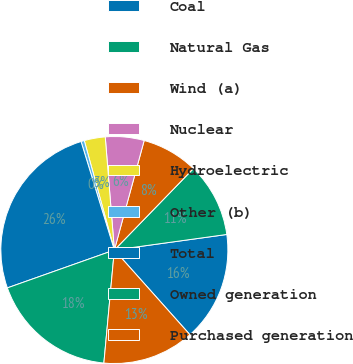<chart> <loc_0><loc_0><loc_500><loc_500><pie_chart><fcel>Coal<fcel>Natural Gas<fcel>Wind (a)<fcel>Nuclear<fcel>Hydroelectric<fcel>Other (b)<fcel>Total<fcel>Owned generation<fcel>Purchased generation<nl><fcel>15.59%<fcel>10.55%<fcel>8.03%<fcel>5.51%<fcel>2.99%<fcel>0.47%<fcel>25.67%<fcel>18.11%<fcel>13.07%<nl></chart> 